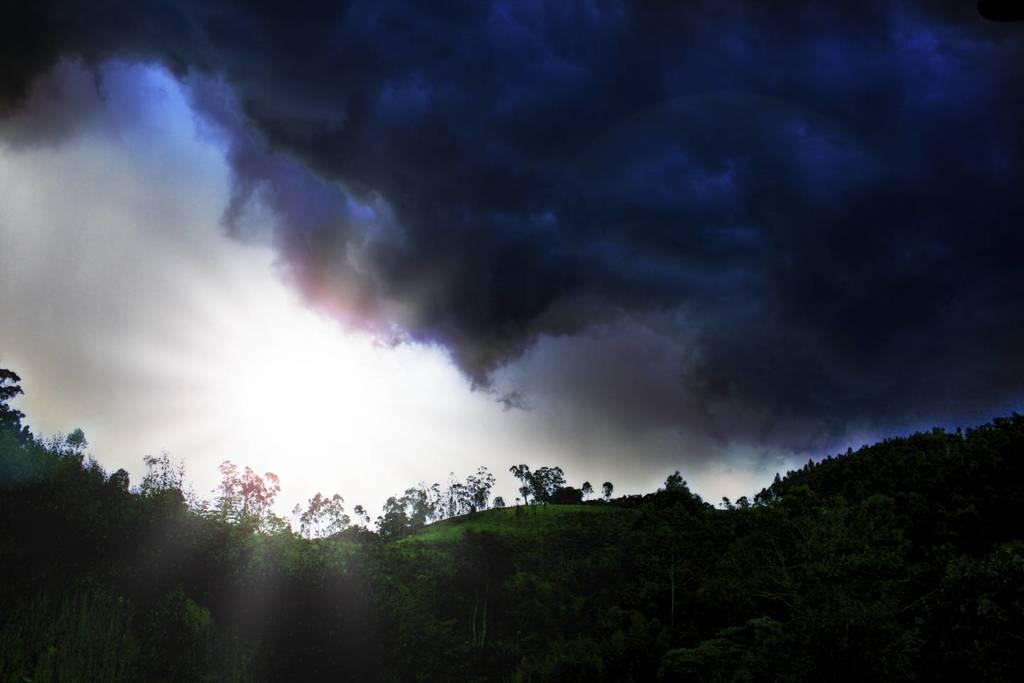What type of vegetation can be seen in the image? There are trees and plants on the ground in the image. What is visible in the sky in the background of the image? There are clouds visible in the sky in the background of the image. What type of rake is being used to gather the list in the image? There is no rake or list present in the image; it features trees, plants, and clouds. 